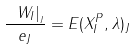Convert formula to latex. <formula><loc_0><loc_0><loc_500><loc_500>\frac { \ W _ { I } | _ { _ { J } } } { e _ { J } } = E ( X _ { I } ^ { P } , \lambda ) _ { J }</formula> 